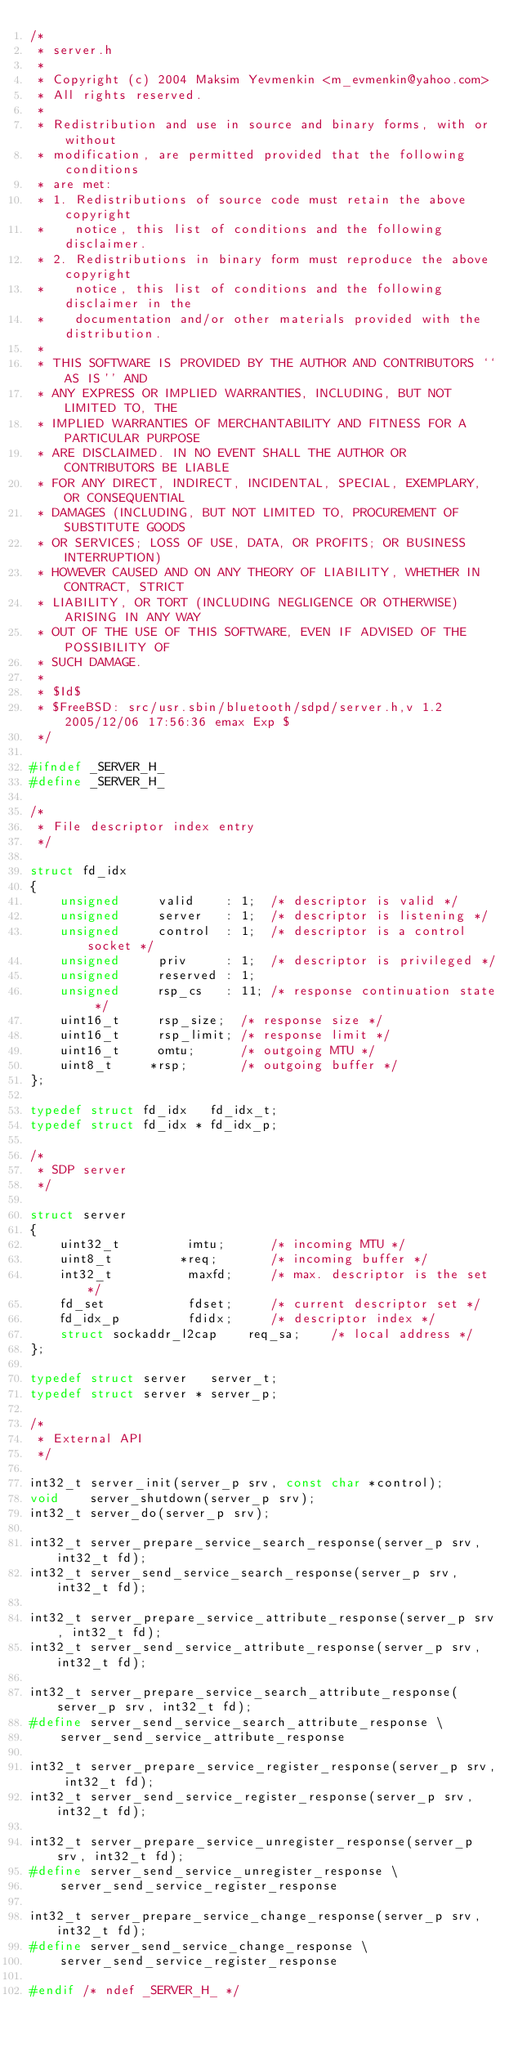<code> <loc_0><loc_0><loc_500><loc_500><_C_>/*
 * server.h
 *
 * Copyright (c) 2004 Maksim Yevmenkin <m_evmenkin@yahoo.com>
 * All rights reserved.
 *
 * Redistribution and use in source and binary forms, with or without
 * modification, are permitted provided that the following conditions
 * are met:
 * 1. Redistributions of source code must retain the above copyright
 *    notice, this list of conditions and the following disclaimer.
 * 2. Redistributions in binary form must reproduce the above copyright
 *    notice, this list of conditions and the following disclaimer in the
 *    documentation and/or other materials provided with the distribution.
 *
 * THIS SOFTWARE IS PROVIDED BY THE AUTHOR AND CONTRIBUTORS ``AS IS'' AND
 * ANY EXPRESS OR IMPLIED WARRANTIES, INCLUDING, BUT NOT LIMITED TO, THE
 * IMPLIED WARRANTIES OF MERCHANTABILITY AND FITNESS FOR A PARTICULAR PURPOSE
 * ARE DISCLAIMED. IN NO EVENT SHALL THE AUTHOR OR CONTRIBUTORS BE LIABLE
 * FOR ANY DIRECT, INDIRECT, INCIDENTAL, SPECIAL, EXEMPLARY, OR CONSEQUENTIAL
 * DAMAGES (INCLUDING, BUT NOT LIMITED TO, PROCUREMENT OF SUBSTITUTE GOODS
 * OR SERVICES; LOSS OF USE, DATA, OR PROFITS; OR BUSINESS INTERRUPTION)
 * HOWEVER CAUSED AND ON ANY THEORY OF LIABILITY, WHETHER IN CONTRACT, STRICT
 * LIABILITY, OR TORT (INCLUDING NEGLIGENCE OR OTHERWISE) ARISING IN ANY WAY
 * OUT OF THE USE OF THIS SOFTWARE, EVEN IF ADVISED OF THE POSSIBILITY OF
 * SUCH DAMAGE.
 *
 * $Id$
 * $FreeBSD: src/usr.sbin/bluetooth/sdpd/server.h,v 1.2 2005/12/06 17:56:36 emax Exp $
 */

#ifndef _SERVER_H_
#define _SERVER_H_

/*
 * File descriptor index entry
 */

struct fd_idx
{
	unsigned	 valid    : 1;	/* descriptor is valid */
	unsigned	 server   : 1;	/* descriptor is listening */
	unsigned	 control  : 1;	/* descriptor is a control socket */
	unsigned	 priv     : 1;	/* descriptor is privileged */
	unsigned	 reserved : 1;
	unsigned	 rsp_cs   : 11; /* response continuation state */
	uint16_t	 rsp_size;	/* response size */
	uint16_t	 rsp_limit;	/* response limit */
	uint16_t	 omtu;		/* outgoing MTU */
	uint8_t		*rsp;		/* outgoing buffer */
};

typedef struct fd_idx	fd_idx_t;
typedef struct fd_idx *	fd_idx_p;

/*
 * SDP server
 */

struct server
{
	uint32_t		 imtu;		/* incoming MTU */
	uint8_t			*req;		/* incoming buffer */
	int32_t			 maxfd;		/* max. descriptor is the set */
	fd_set			 fdset;		/* current descriptor set */
	fd_idx_p		 fdidx;		/* descriptor index */
	struct sockaddr_l2cap	 req_sa;	/* local address */
};

typedef struct server	server_t;
typedef struct server *	server_p;

/*
 * External API
 */

int32_t	server_init(server_p srv, const char *control);
void	server_shutdown(server_p srv);
int32_t	server_do(server_p srv);

int32_t	server_prepare_service_search_response(server_p srv, int32_t fd);
int32_t	server_send_service_search_response(server_p srv, int32_t fd);

int32_t	server_prepare_service_attribute_response(server_p srv, int32_t fd);
int32_t	server_send_service_attribute_response(server_p srv, int32_t fd);

int32_t	server_prepare_service_search_attribute_response(server_p srv, int32_t fd);
#define	server_send_service_search_attribute_response \
	server_send_service_attribute_response

int32_t	server_prepare_service_register_response(server_p srv, int32_t fd);
int32_t	server_send_service_register_response(server_p srv, int32_t fd);

int32_t	server_prepare_service_unregister_response(server_p srv, int32_t fd);
#define	server_send_service_unregister_response \
	server_send_service_register_response

int32_t	server_prepare_service_change_response(server_p srv, int32_t fd);
#define	server_send_service_change_response \
	server_send_service_register_response

#endif /* ndef _SERVER_H_ */
</code> 